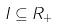Convert formula to latex. <formula><loc_0><loc_0><loc_500><loc_500>I \subseteq R _ { + }</formula> 